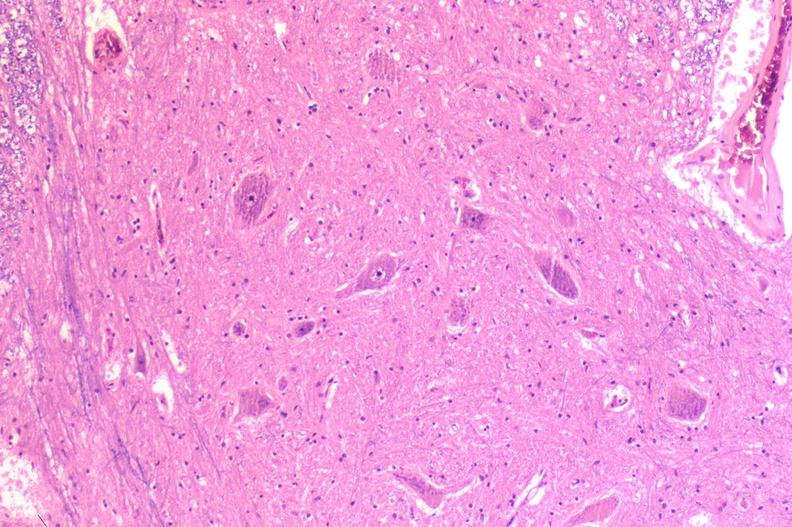does this image show spinal cord injury due to vertebral column trauma, demyelination?
Answer the question using a single word or phrase. Yes 